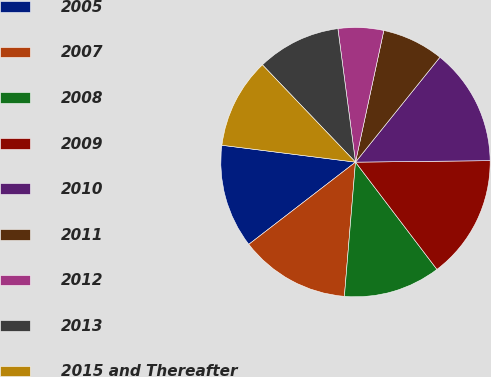<chart> <loc_0><loc_0><loc_500><loc_500><pie_chart><fcel>2005<fcel>2007<fcel>2008<fcel>2009<fcel>2010<fcel>2011<fcel>2012<fcel>2013<fcel>2015 and Thereafter<nl><fcel>12.45%<fcel>13.24%<fcel>11.65%<fcel>14.84%<fcel>14.04%<fcel>7.41%<fcel>5.46%<fcel>10.06%<fcel>10.85%<nl></chart> 